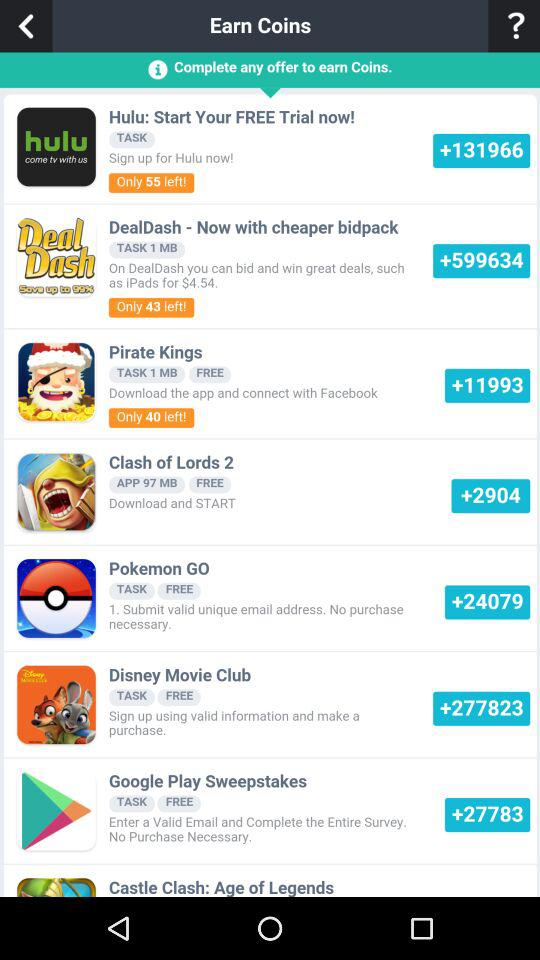Is "Pokemon Go" free or paid? "Pokemon Go" is free. 